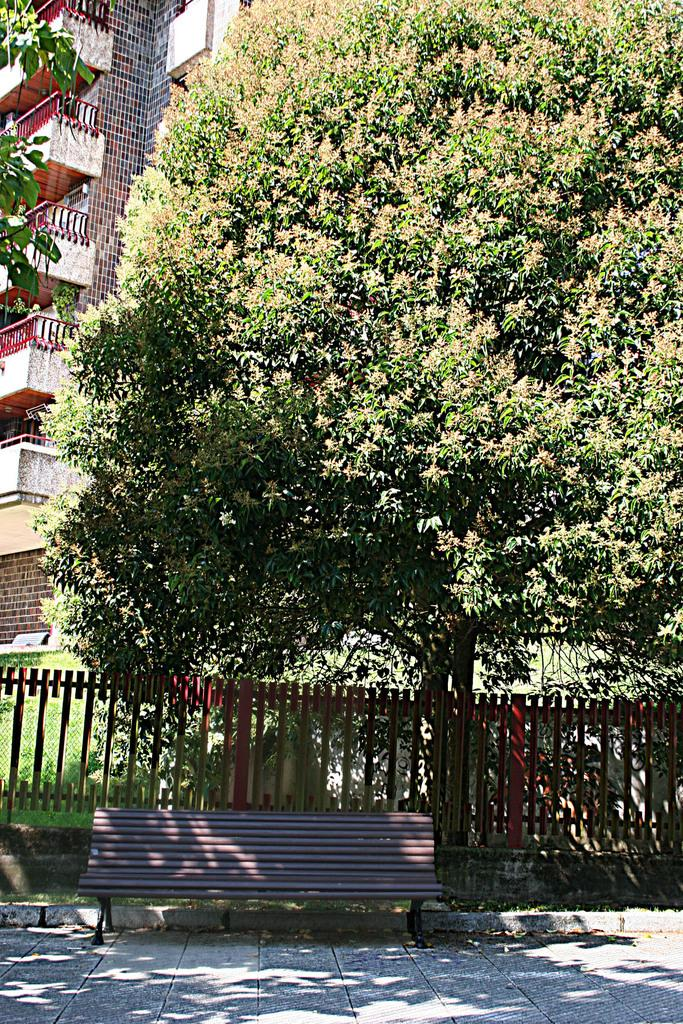What type of seating is visible at the bottom of the image? There is a bench at the bottom side of the image. What is located behind the bench? There is a boundary behind the bench. What can be seen in the distance in the image? There are buildings and greenery in the background of the image. What type of toothpaste is being used to maintain the greenery in the image? There is no toothpaste present in the image, and it is not used for maintaining greenery. 